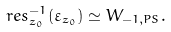<formula> <loc_0><loc_0><loc_500><loc_500>r e s _ { z _ { 0 } } ^ { - 1 } ( \varepsilon _ { z _ { 0 } } ) \simeq W _ { - 1 , P S } .</formula> 